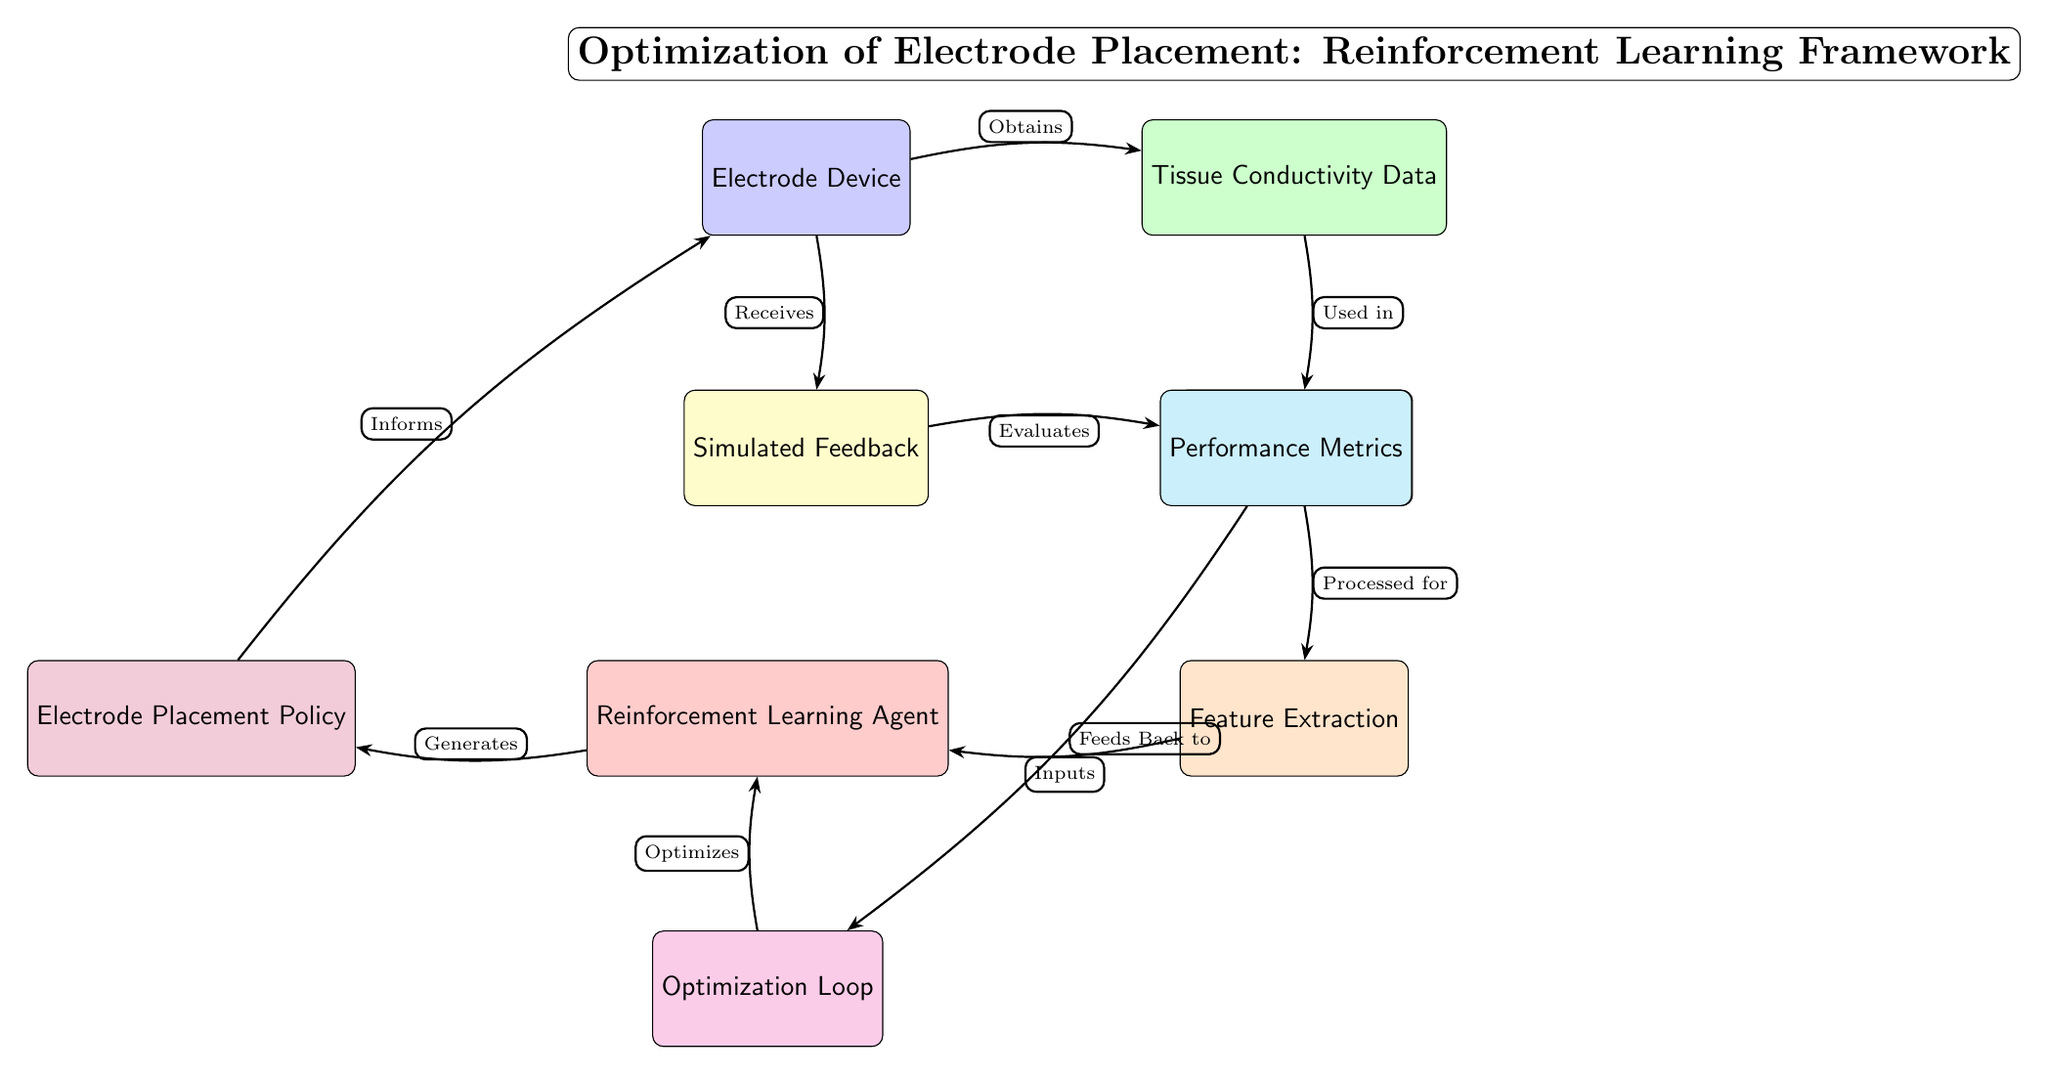What is the first node in the diagram? The first node in the diagram represents the "Electrode Device," which is depicted at the top left.
Answer: Electrode Device How many nodes are in the diagram? By counting all the boxes in the diagram representing the various components, we find a total of eight nodes.
Answer: Eight What type of data is used in the "Data Preprocessing" node? The "Data Preprocessing" node uses "Tissue Conductivity Data," which is shown coming from the "Tissue Conductivity Data" node.
Answer: Tissue Conductivity Data Which node informs the "Electrode Device"? The "Electrode Placement Policy" node informs the "Electrode Device," as indicated by the arrow pointing from the policy node to the device node.
Answer: Electrode Placement Policy What is the output of the "Feedback" node evaluated against? The output of the "Feedback" node is evaluated against the "Performance Metrics," which are shown as the next node in the flow from feedback.
Answer: Performance Metrics What is the main role of the "Reinforcement Learning Agent"? The main role of the "Reinforcement Learning Agent" is to generate an "Electrode Placement Policy," highlighting its function in the reinforcement learning framework.
Answer: Generates Which node optimizes the "Reinforcement Learning Agent"? The "Optimization Loop" is the node responsible for optimizing the "Reinforcement Learning Agent," indicated by the arrow leading back from optimization to the agent.
Answer: Optimization Loop What does the "Simulated Feedback" node receive? The "Simulated Feedback" node receives information from the "Electrode Device," as shown by the arrow pointing from the device node to the feedback node.
Answer: Electrode Device 